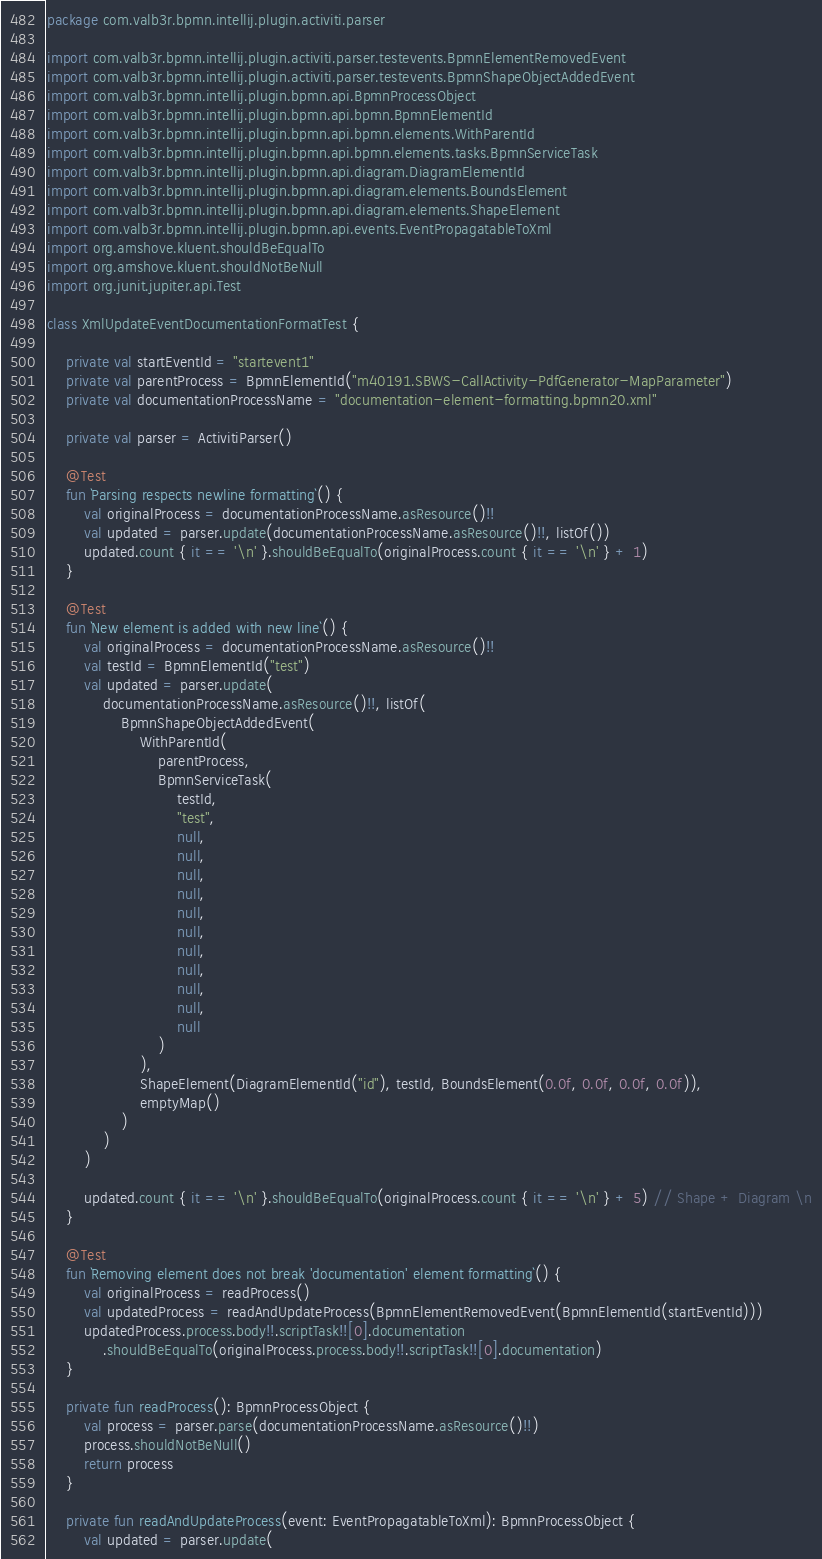Convert code to text. <code><loc_0><loc_0><loc_500><loc_500><_Kotlin_>package com.valb3r.bpmn.intellij.plugin.activiti.parser

import com.valb3r.bpmn.intellij.plugin.activiti.parser.testevents.BpmnElementRemovedEvent
import com.valb3r.bpmn.intellij.plugin.activiti.parser.testevents.BpmnShapeObjectAddedEvent
import com.valb3r.bpmn.intellij.plugin.bpmn.api.BpmnProcessObject
import com.valb3r.bpmn.intellij.plugin.bpmn.api.bpmn.BpmnElementId
import com.valb3r.bpmn.intellij.plugin.bpmn.api.bpmn.elements.WithParentId
import com.valb3r.bpmn.intellij.plugin.bpmn.api.bpmn.elements.tasks.BpmnServiceTask
import com.valb3r.bpmn.intellij.plugin.bpmn.api.diagram.DiagramElementId
import com.valb3r.bpmn.intellij.plugin.bpmn.api.diagram.elements.BoundsElement
import com.valb3r.bpmn.intellij.plugin.bpmn.api.diagram.elements.ShapeElement
import com.valb3r.bpmn.intellij.plugin.bpmn.api.events.EventPropagatableToXml
import org.amshove.kluent.shouldBeEqualTo
import org.amshove.kluent.shouldNotBeNull
import org.junit.jupiter.api.Test

class XmlUpdateEventDocumentationFormatTest {

    private val startEventId = "startevent1"
    private val parentProcess = BpmnElementId("m40191.SBWS-CallActivity-PdfGenerator-MapParameter")
    private val documentationProcessName = "documentation-element-formatting.bpmn20.xml"

    private val parser = ActivitiParser()

    @Test
    fun `Parsing respects newline formatting`() {
        val originalProcess = documentationProcessName.asResource()!!
        val updated = parser.update(documentationProcessName.asResource()!!, listOf())
        updated.count { it == '\n' }.shouldBeEqualTo(originalProcess.count { it == '\n' } + 1)
    }

    @Test
    fun `New element is added with new line`() {
        val originalProcess = documentationProcessName.asResource()!!
        val testId = BpmnElementId("test")
        val updated = parser.update(
            documentationProcessName.asResource()!!, listOf(
                BpmnShapeObjectAddedEvent(
                    WithParentId(
                        parentProcess,
                        BpmnServiceTask(
                            testId,
                            "test",
                            null,
                            null,
                            null,
                            null,
                            null,
                            null,
                            null,
                            null,
                            null,
                            null,
                            null
                        )
                    ),
                    ShapeElement(DiagramElementId("id"), testId, BoundsElement(0.0f, 0.0f, 0.0f, 0.0f)),
                    emptyMap()
                )
            )
        )

        updated.count { it == '\n' }.shouldBeEqualTo(originalProcess.count { it == '\n' } + 5) // Shape + Diagram \n
    }

    @Test
    fun `Removing element does not break 'documentation' element formatting`() {
        val originalProcess = readProcess()
        val updatedProcess = readAndUpdateProcess(BpmnElementRemovedEvent(BpmnElementId(startEventId)))
        updatedProcess.process.body!!.scriptTask!![0].documentation
            .shouldBeEqualTo(originalProcess.process.body!!.scriptTask!![0].documentation)
    }

    private fun readProcess(): BpmnProcessObject {
        val process = parser.parse(documentationProcessName.asResource()!!)
        process.shouldNotBeNull()
        return process
    }

    private fun readAndUpdateProcess(event: EventPropagatableToXml): BpmnProcessObject {
        val updated = parser.update(</code> 